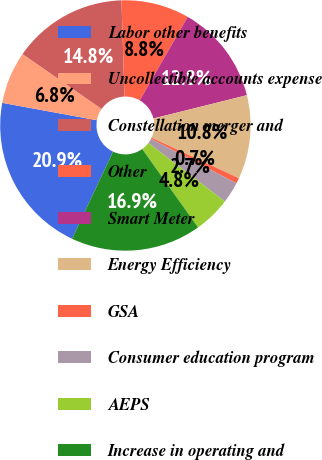<chart> <loc_0><loc_0><loc_500><loc_500><pie_chart><fcel>Labor other benefits<fcel>Uncollectible accounts expense<fcel>Constellation merger and<fcel>Other<fcel>Smart Meter<fcel>Energy Efficiency<fcel>GSA<fcel>Consumer education program<fcel>AEPS<fcel>Increase in operating and<nl><fcel>20.89%<fcel>6.77%<fcel>14.84%<fcel>8.79%<fcel>12.82%<fcel>10.81%<fcel>0.72%<fcel>2.74%<fcel>4.76%<fcel>16.86%<nl></chart> 